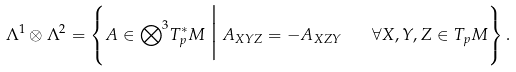<formula> <loc_0><loc_0><loc_500><loc_500>\Lambda ^ { 1 } \otimes \Lambda ^ { 2 } = \left \{ A \in { \bigotimes } ^ { 3 } T ^ { * } _ { p } M \, \Big | \, A _ { X Y Z } = - A _ { X Z Y } \quad \forall X , Y , Z \in T _ { p } M \right \} .</formula> 